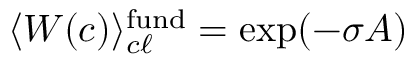<formula> <loc_0><loc_0><loc_500><loc_500>\langle W ( c ) \rangle _ { c \ell } ^ { f u n d } = \exp ( - \sigma A )</formula> 